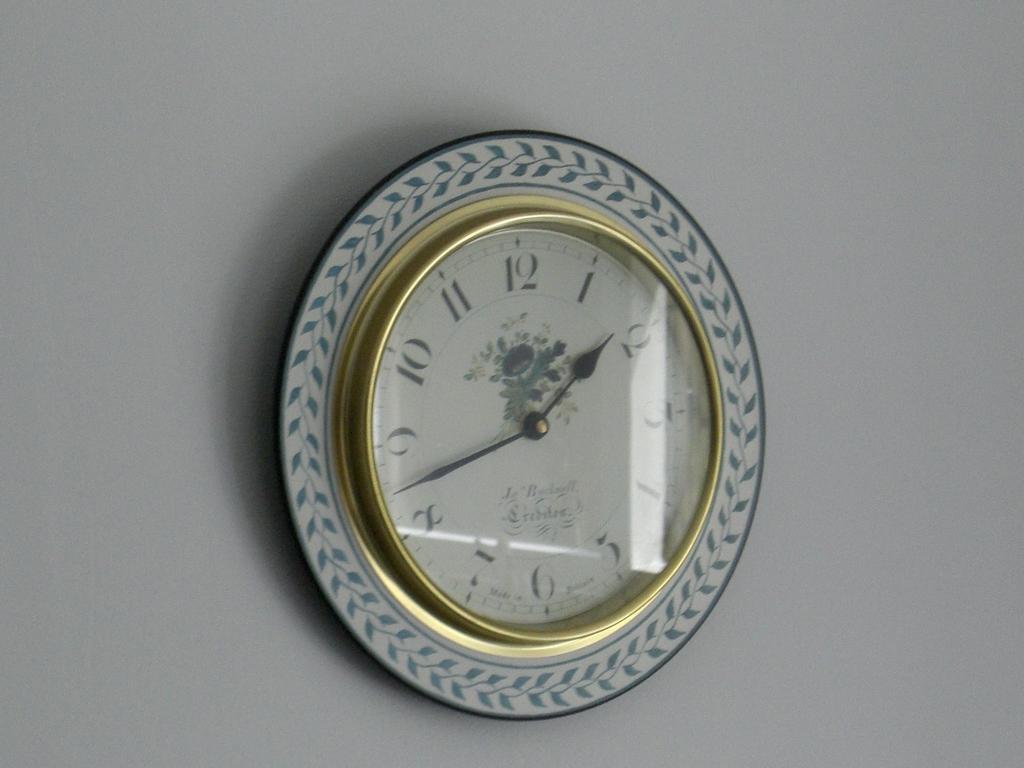What time is it?
Make the answer very short. 1:43. 